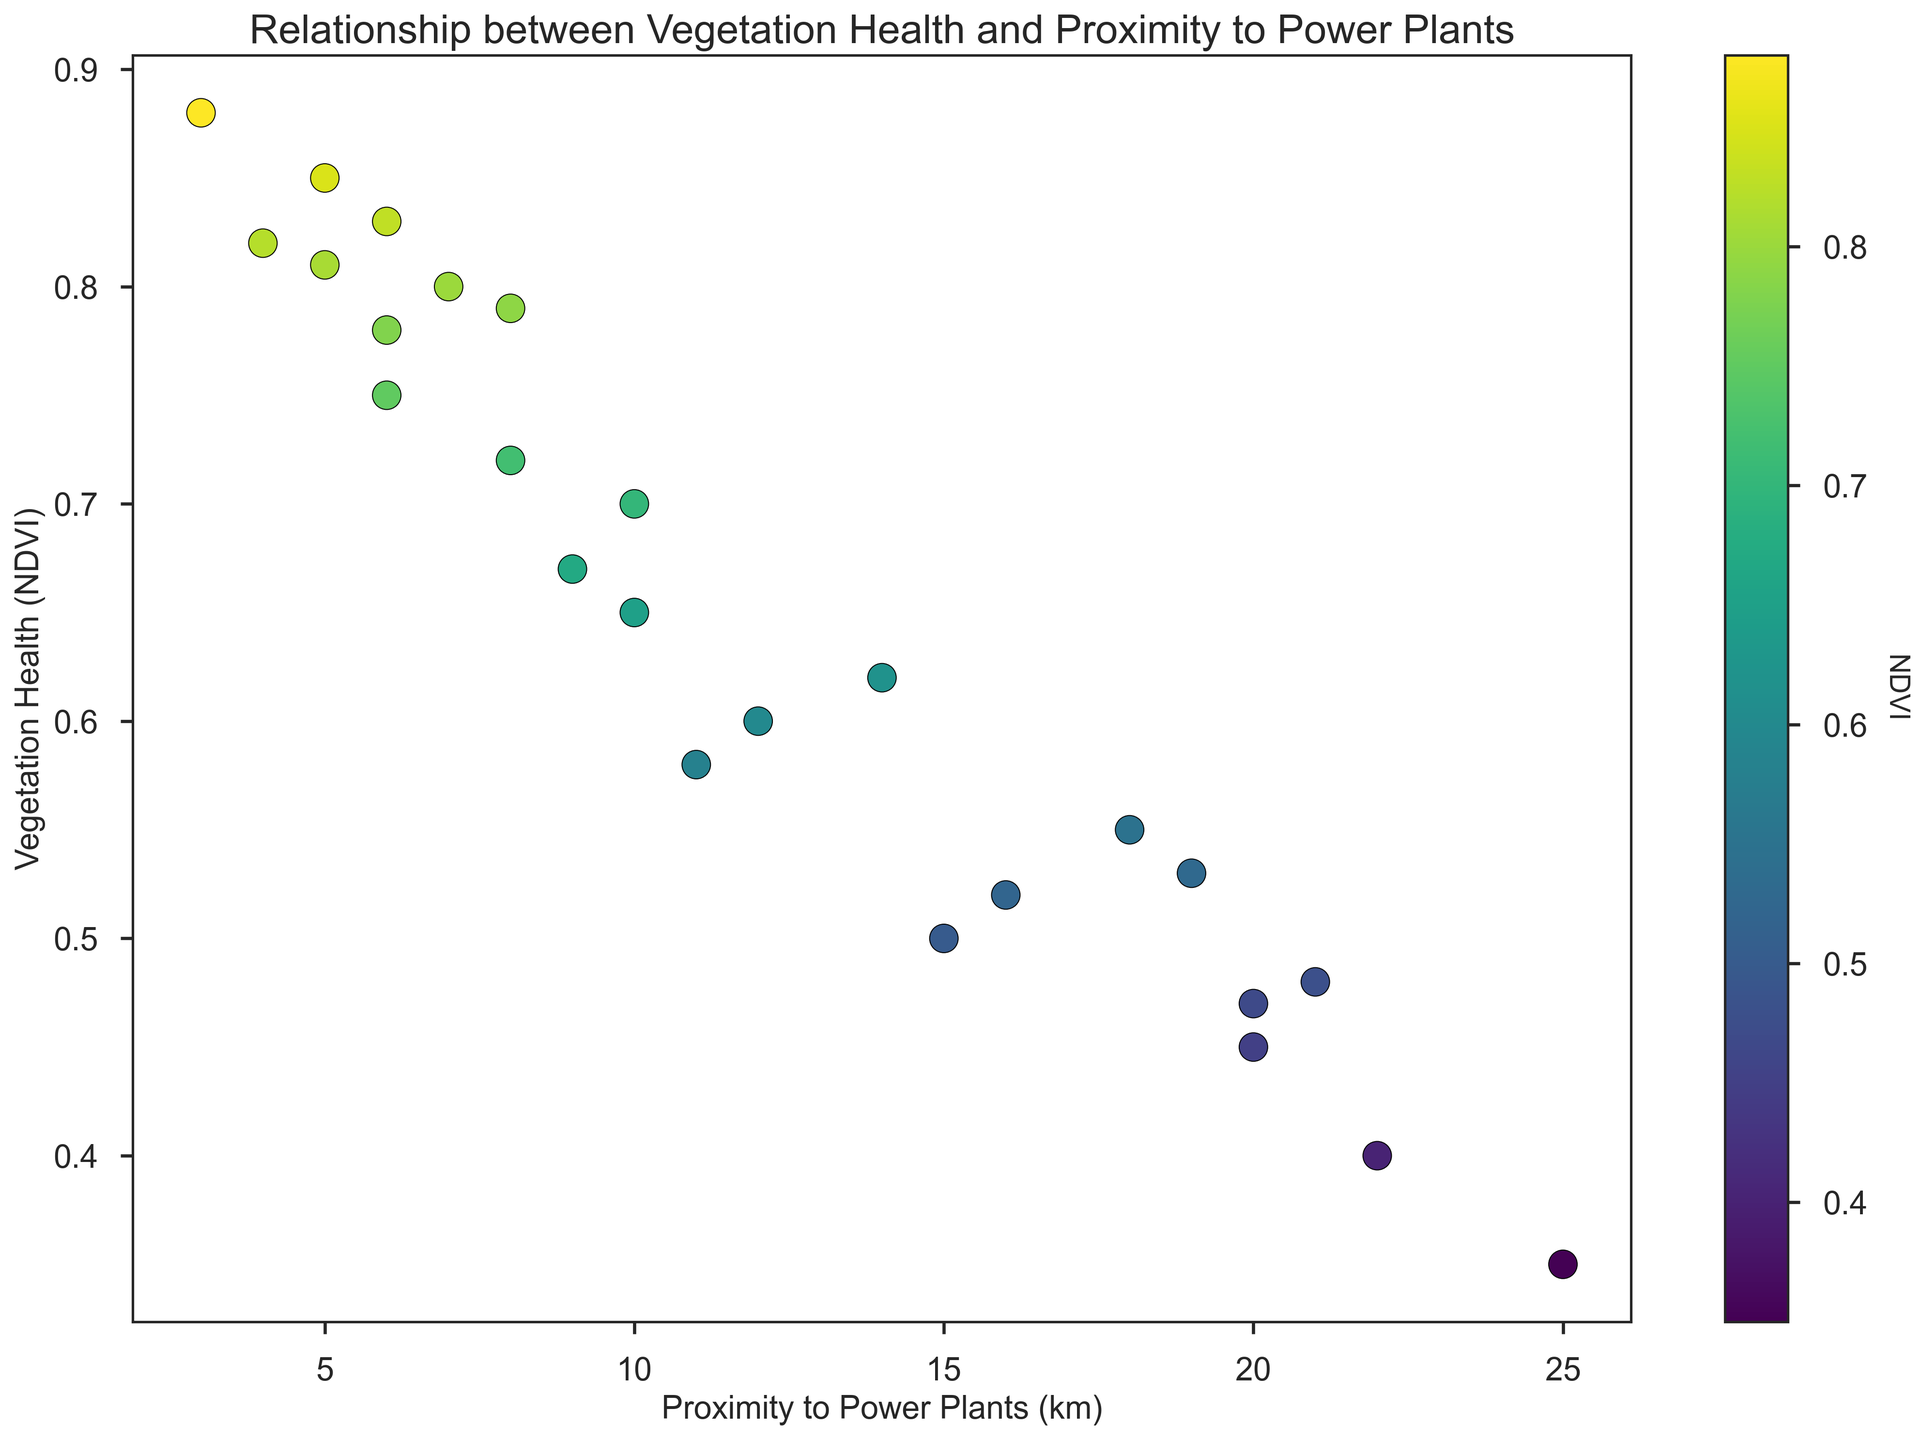What is the general trend between the proximity to power plants and vegetation health? By observing the scatter plot, the general trend shows that as the proximity to power plants decreases (closer to power plants), the NDVI value, which indicates vegetation health, tends to increase. This suggests that vegetation health seems to get better as you move further away from power plants.
Answer: Vegetation health improves as you move away from power plants Which data point represents the highest NDVI value and how far is it from the power plant? Looking at the scatter plot, the data point with the highest NDVI value (0.88) is at a proximity of 3 km from the power plant.
Answer: 0.88 at 3 km How many data points have an NDVI value below 0.60? By counting the data points in the scatter plot that fall below the NDVI value of 0.60, we can identify that there are 8 such points.
Answer: 8 Is the vegetation health above or below 0.65 for a site that is 10 km away from a power plant? Referring to the data points on the scatter plot, the data point corresponding to the 10 km proximity falls slightly below the 0.65 NDVI value.
Answer: Below 0.65 What NDVI value corresponds to the site located 25 km away from a power plant? From the scatter plot, we can identify the NDVI value corresponding to 25 km, which is around 0.35.
Answer: 0.35 Compare the NDVI values at 5 km and 15 km from the power plant. Which one has higher vegetation health? Looking at the scatter plot, the NDVI values around 5 km are generally higher (0.85, 0.82, 0.81) compared to the values around 15 km (0.50, 0.52). Hence, the vegetation health at 5 km is higher.
Answer: 5 km What is the average NDVI value for sites within 10 km of a power plant? To find the average, add the NDVI values of all points within 10 km (0.85, 0.80, 0.78, 0.72, 0.82, 0.88, 0.81, 0.67, 0.79, 0.83, 0.75) then divide by their count (11): (0.85 + 0.80 + 0.78 + 0.72 + 0.82 + 0.88 + 0.81 + 0.67 + 0.79 + 0.83 + 0.75) / 11 ≈ 0.78.
Answer: 0.78 Are there any outliers in the data, and if so, what NDVI values do they represent? Observing the scatter plot, there are no significant outliers as the data points are relatively evenly dispersed without any points that are markedly distinct compared to the majority of the data.
Answer: No significant outliers Which sites, if any, have identical NDVI values and what are their distances from the power plant? From the plotted data, there are no sites with identical NDVI values; each NDVI value is unique across different proximities.
Answer: None 